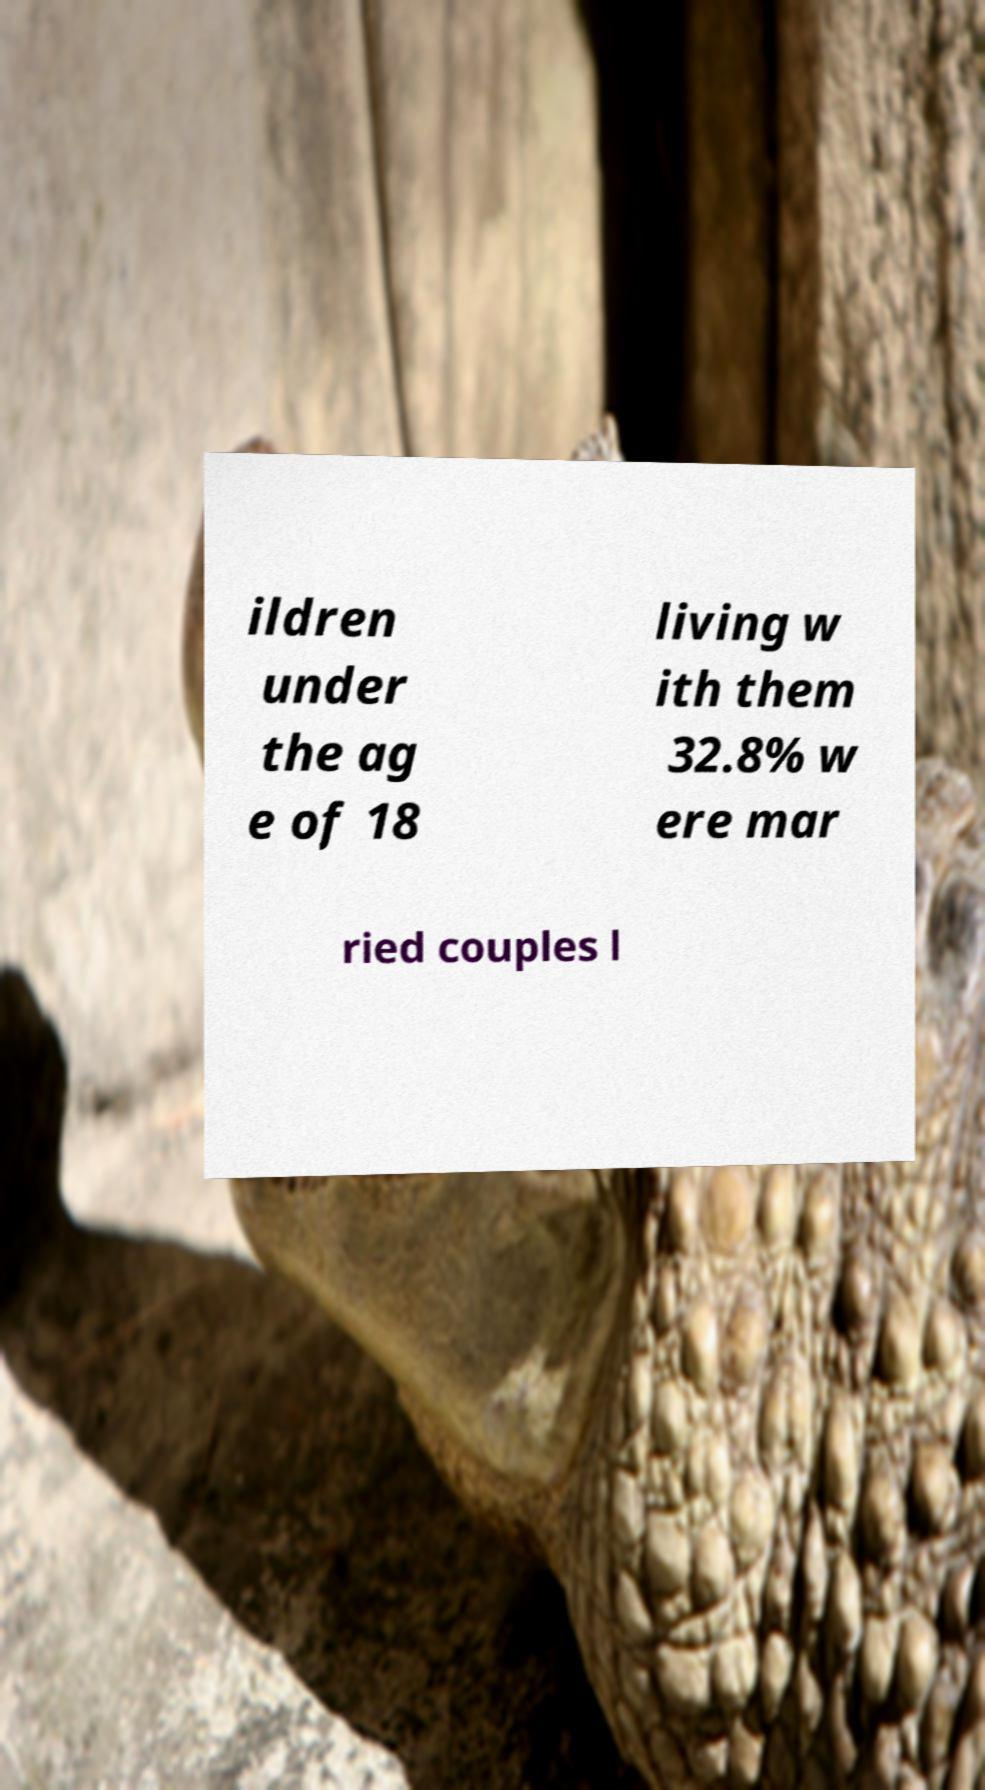Can you read and provide the text displayed in the image?This photo seems to have some interesting text. Can you extract and type it out for me? ildren under the ag e of 18 living w ith them 32.8% w ere mar ried couples l 